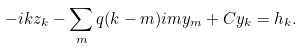Convert formula to latex. <formula><loc_0><loc_0><loc_500><loc_500>- i k z _ { k } - \sum _ { m } q ( k - m ) i m y _ { m } + C y _ { k } = h _ { k } .</formula> 